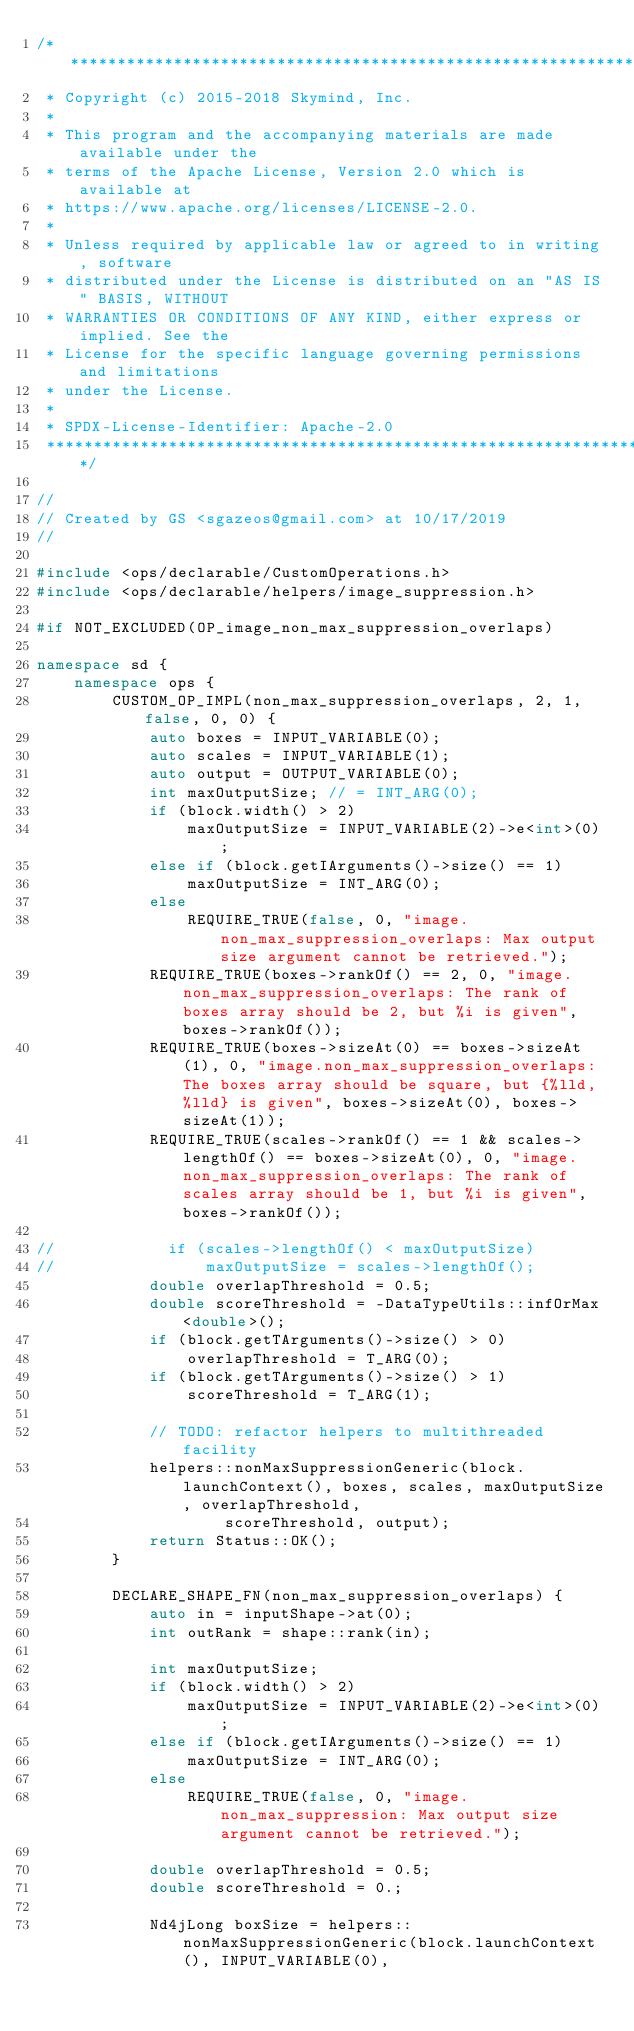Convert code to text. <code><loc_0><loc_0><loc_500><loc_500><_C++_>/*******************************************************************************
 * Copyright (c) 2015-2018 Skymind, Inc.
 *
 * This program and the accompanying materials are made available under the
 * terms of the Apache License, Version 2.0 which is available at
 * https://www.apache.org/licenses/LICENSE-2.0.
 *
 * Unless required by applicable law or agreed to in writing, software
 * distributed under the License is distributed on an "AS IS" BASIS, WITHOUT
 * WARRANTIES OR CONDITIONS OF ANY KIND, either express or implied. See the
 * License for the specific language governing permissions and limitations
 * under the License.
 *
 * SPDX-License-Identifier: Apache-2.0
 ******************************************************************************/

//
// Created by GS <sgazeos@gmail.com> at 10/17/2019
//

#include <ops/declarable/CustomOperations.h>
#include <ops/declarable/helpers/image_suppression.h>

#if NOT_EXCLUDED(OP_image_non_max_suppression_overlaps)

namespace sd {
    namespace ops {
        CUSTOM_OP_IMPL(non_max_suppression_overlaps, 2, 1, false, 0, 0) {
            auto boxes = INPUT_VARIABLE(0);
            auto scales = INPUT_VARIABLE(1);
            auto output = OUTPUT_VARIABLE(0);
            int maxOutputSize; // = INT_ARG(0);
            if (block.width() > 2)
                maxOutputSize = INPUT_VARIABLE(2)->e<int>(0);
            else if (block.getIArguments()->size() == 1)
                maxOutputSize = INT_ARG(0);
            else
                REQUIRE_TRUE(false, 0, "image.non_max_suppression_overlaps: Max output size argument cannot be retrieved.");
            REQUIRE_TRUE(boxes->rankOf() == 2, 0, "image.non_max_suppression_overlaps: The rank of boxes array should be 2, but %i is given", boxes->rankOf());
            REQUIRE_TRUE(boxes->sizeAt(0) == boxes->sizeAt(1), 0, "image.non_max_suppression_overlaps: The boxes array should be square, but {%lld, %lld} is given", boxes->sizeAt(0), boxes->sizeAt(1));
            REQUIRE_TRUE(scales->rankOf() == 1 && scales->lengthOf() == boxes->sizeAt(0), 0, "image.non_max_suppression_overlaps: The rank of scales array should be 1, but %i is given", boxes->rankOf());

//            if (scales->lengthOf() < maxOutputSize)
//                maxOutputSize = scales->lengthOf();
            double overlapThreshold = 0.5;
            double scoreThreshold = -DataTypeUtils::infOrMax<double>();
            if (block.getTArguments()->size() > 0)
                overlapThreshold = T_ARG(0);
            if (block.getTArguments()->size() > 1)
                scoreThreshold = T_ARG(1);

            // TODO: refactor helpers to multithreaded facility
            helpers::nonMaxSuppressionGeneric(block.launchContext(), boxes, scales, maxOutputSize, overlapThreshold,
                    scoreThreshold, output);
            return Status::OK();
        }

        DECLARE_SHAPE_FN(non_max_suppression_overlaps) {
            auto in = inputShape->at(0);
            int outRank = shape::rank(in);

            int maxOutputSize;
            if (block.width() > 2)
                maxOutputSize = INPUT_VARIABLE(2)->e<int>(0);
            else if (block.getIArguments()->size() == 1)
                maxOutputSize = INT_ARG(0);
            else
                REQUIRE_TRUE(false, 0, "image.non_max_suppression: Max output size argument cannot be retrieved.");

            double overlapThreshold = 0.5;
            double scoreThreshold = 0.;

            Nd4jLong boxSize = helpers::nonMaxSuppressionGeneric(block.launchContext(), INPUT_VARIABLE(0),</code> 